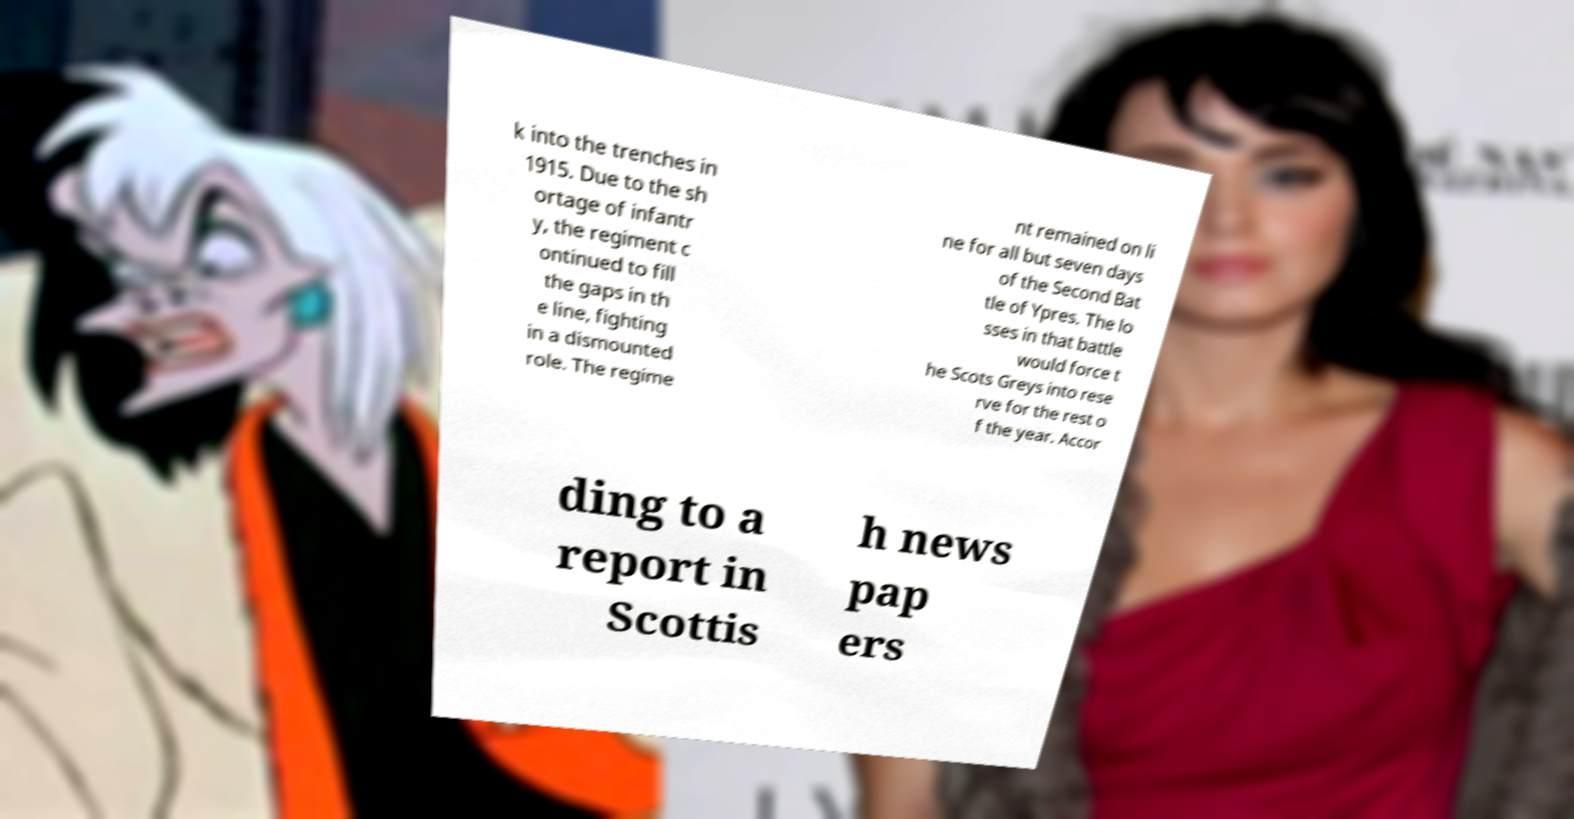Please identify and transcribe the text found in this image. k into the trenches in 1915. Due to the sh ortage of infantr y, the regiment c ontinued to fill the gaps in th e line, fighting in a dismounted role. The regime nt remained on li ne for all but seven days of the Second Bat tle of Ypres. The lo sses in that battle would force t he Scots Greys into rese rve for the rest o f the year. Accor ding to a report in Scottis h news pap ers 